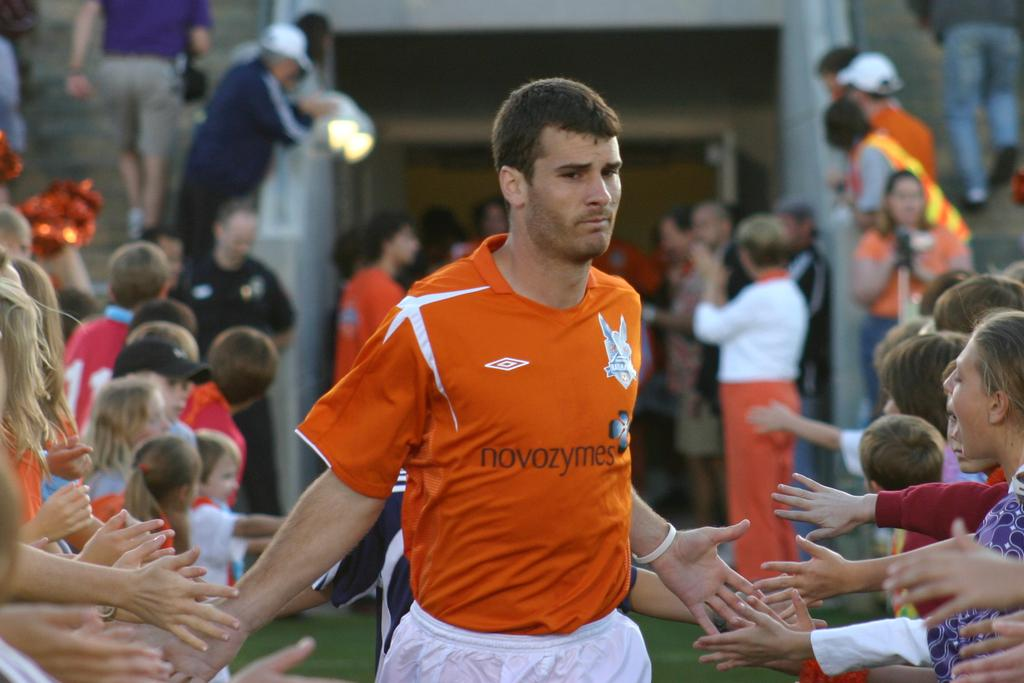<image>
Write a terse but informative summary of the picture. a man with an orange shirt that has the word novozymes on it 